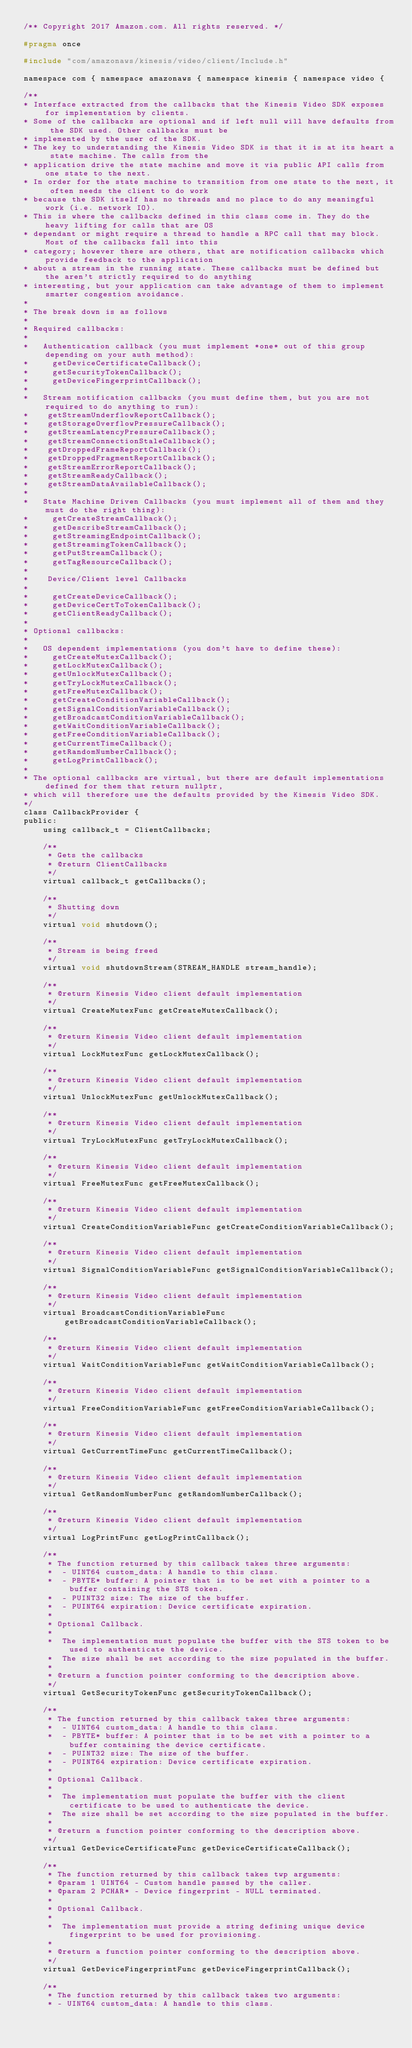Convert code to text. <code><loc_0><loc_0><loc_500><loc_500><_C_>/** Copyright 2017 Amazon.com. All rights reserved. */

#pragma once

#include "com/amazonaws/kinesis/video/client/Include.h"

namespace com { namespace amazonaws { namespace kinesis { namespace video {

/**
* Interface extracted from the callbacks that the Kinesis Video SDK exposes for implementation by clients.
* Some of the callbacks are optional and if left null will have defaults from the SDK used. Other callbacks must be
* implemented by the user of the SDK.
* The key to understanding the Kinesis Video SDK is that it is at its heart a state machine. The calls from the
* application drive the state machine and move it via public API calls from one state to the next.
* In order for the state machine to transition from one state to the next, it often needs the client to do work
* because the SDK itself has no threads and no place to do any meaningful work (i.e. network IO).
* This is where the callbacks defined in this class come in. They do the heavy lifting for calls that are OS
* dependant or might require a thread to handle a RPC call that may block. Most of the callbacks fall into this
* category; however there are others, that are notification callbacks which provide feedback to the application
* about a stream in the running state. These callbacks must be defined but the aren't strictly required to do anything
* interesting, but your application can take advantage of them to implement smarter congestion avoidance.
*
* The break down is as follows
*
* Required callbacks:
*
*   Authentication callback (you must implement *one* out of this group depending on your auth method):
*     getDeviceCertificateCallback();
*     getSecurityTokenCallback();
*     getDeviceFingerprintCallback();
*
*   Stream notification callbacks (you must define them, but you are not required to do anything to run):
*    getStreamUnderflowReportCallback();
*    getStorageOverflowPressureCallback();
*    getStreamLatencyPressureCallback();
*    getStreamConnectionStaleCallback();
*    getDroppedFrameReportCallback();
*    getDroppedFragmentReportCallback();
*    getStreamErrorReportCallback();
*    getStreamReadyCallback();
*    getStreamDataAvailableCallback();
*
*   State Machine Driven Callbacks (you must implement all of them and they must do the right thing):
*     getCreateStreamCallback();
*     getDescribeStreamCallback();
*     getStreamingEndpointCallback();
*     getStreamingTokenCallback();
*     getPutStreamCallback();
*     getTagResourceCallback();
*
*    Device/Client level Callbacks
*
*     getCreateDeviceCallback();
*     getDeviceCertToTokenCallback();
*     getClientReadyCallback();
*
* Optional callbacks:
*
*   OS dependent implementations (you don't have to define these):
*     getCreateMutexCallback();
*     getLockMutexCallback();
*     getUnlockMutexCallback();
*     getTryLockMutexCallback();
*     getFreeMutexCallback();
*     getCreateConditionVariableCallback();
*     getSignalConditionVariableCallback();
*     getBroadcastConditionVariableCallback();
*     getWaitConditionVariableCallback();
*     getFreeConditionVariableCallback();
*     getCurrentTimeCallback();
*     getRandomNumberCallback();
*     getLogPrintCallback();
*
* The optional callbacks are virtual, but there are default implementations defined for them that return nullptr,
* which will therefore use the defaults provided by the Kinesis Video SDK.
*/
class CallbackProvider {
public:
    using callback_t = ClientCallbacks;

    /**
     * Gets the callbacks
     * @return ClientCallbacks
     */
    virtual callback_t getCallbacks();

    /**
     * Shutting down
     */
    virtual void shutdown();

    /**
     * Stream is being freed
     */
    virtual void shutdownStream(STREAM_HANDLE stream_handle);

    /**
     * @return Kinesis Video client default implementation
     */
    virtual CreateMutexFunc getCreateMutexCallback();

    /**
     * @return Kinesis Video client default implementation
     */
    virtual LockMutexFunc getLockMutexCallback();

    /**
     * @return Kinesis Video client default implementation
     */
    virtual UnlockMutexFunc getUnlockMutexCallback();

    /**
     * @return Kinesis Video client default implementation
     */
    virtual TryLockMutexFunc getTryLockMutexCallback();

    /**
     * @return Kinesis Video client default implementation
     */
    virtual FreeMutexFunc getFreeMutexCallback();

    /**
     * @return Kinesis Video client default implementation
     */
    virtual CreateConditionVariableFunc getCreateConditionVariableCallback();

    /**
     * @return Kinesis Video client default implementation
     */
    virtual SignalConditionVariableFunc getSignalConditionVariableCallback();

    /**
     * @return Kinesis Video client default implementation
     */
    virtual BroadcastConditionVariableFunc getBroadcastConditionVariableCallback();

    /**
     * @return Kinesis Video client default implementation
     */
    virtual WaitConditionVariableFunc getWaitConditionVariableCallback();

    /**
     * @return Kinesis Video client default implementation
     */
    virtual FreeConditionVariableFunc getFreeConditionVariableCallback();

    /**
     * @return Kinesis Video client default implementation
     */
    virtual GetCurrentTimeFunc getCurrentTimeCallback();

    /**
     * @return Kinesis Video client default implementation
     */
    virtual GetRandomNumberFunc getRandomNumberCallback();

    /**
     * @return Kinesis Video client default implementation
     */
    virtual LogPrintFunc getLogPrintCallback();

    /**
     * The function returned by this callback takes three arguments:
     *  - UINT64 custom_data: A handle to this class.
     *  - PBYTE* buffer: A pointer that is to be set with a pointer to a buffer containing the STS token.
     *  - PUINT32 size: The size of the buffer.
     *  - PUINT64 expiration: Device certificate expiration.
     *
     * Optional Callback.
     *
     *  The implementation must populate the buffer with the STS token to be used to authenticate the device.
     *  The size shall be set according to the size populated in the buffer.
     *
     * @return a function pointer conforming to the description above.
     */
    virtual GetSecurityTokenFunc getSecurityTokenCallback();

    /**
     * The function returned by this callback takes three arguments:
     *  - UINT64 custom_data: A handle to this class.
     *  - PBYTE* buffer: A pointer that is to be set with a pointer to a buffer containing the device certificate.
     *  - PUINT32 size: The size of the buffer.
     *  - PUINT64 expiration: Device certificate expiration.
     *
     * Optional Callback.
     *
     *  The implementation must populate the buffer with the client certificate to be used to authenticate the device.
     *  The size shall be set according to the size populated in the buffer.
     *
     * @return a function pointer conforming to the description above.
     */
    virtual GetDeviceCertificateFunc getDeviceCertificateCallback();

    /**
     * The function returned by this callback takes twp arguments:
     * @param 1 UINT64 - Custom handle passed by the caller.
     * @param 2 PCHAR* - Device fingerprint - NULL terminated.
     *
     * Optional Callback.
     *
     *  The implementation must provide a string defining unique device fingerprint to be used for provisioning.
     *
     * @return a function pointer conforming to the description above.
     */
    virtual GetDeviceFingerprintFunc getDeviceFingerprintCallback();

    /**
     * The function returned by this callback takes two arguments:
     * - UINT64 custom_data: A handle to this class.</code> 